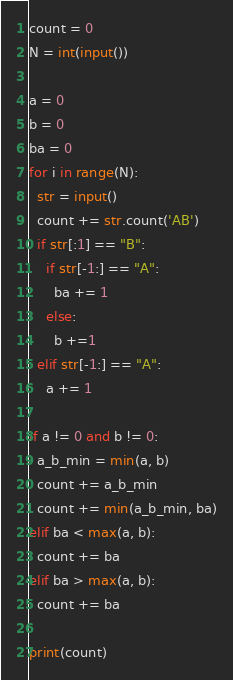<code> <loc_0><loc_0><loc_500><loc_500><_Python_>count = 0
N = int(input())

a = 0
b = 0
ba = 0
for i in range(N):
  str = input()
  count += str.count('AB')
  if str[:1] == "B":
    if str[-1:] == "A":
      ba += 1
    else:
      b +=1
  elif str[-1:] == "A":
    a += 1

if a != 0 and b != 0:
  a_b_min = min(a, b)
  count += a_b_min
  count += min(a_b_min, ba)
elif ba < max(a, b):
  count += ba
elif ba > max(a, b):
  count += ba
  
print(count)</code> 